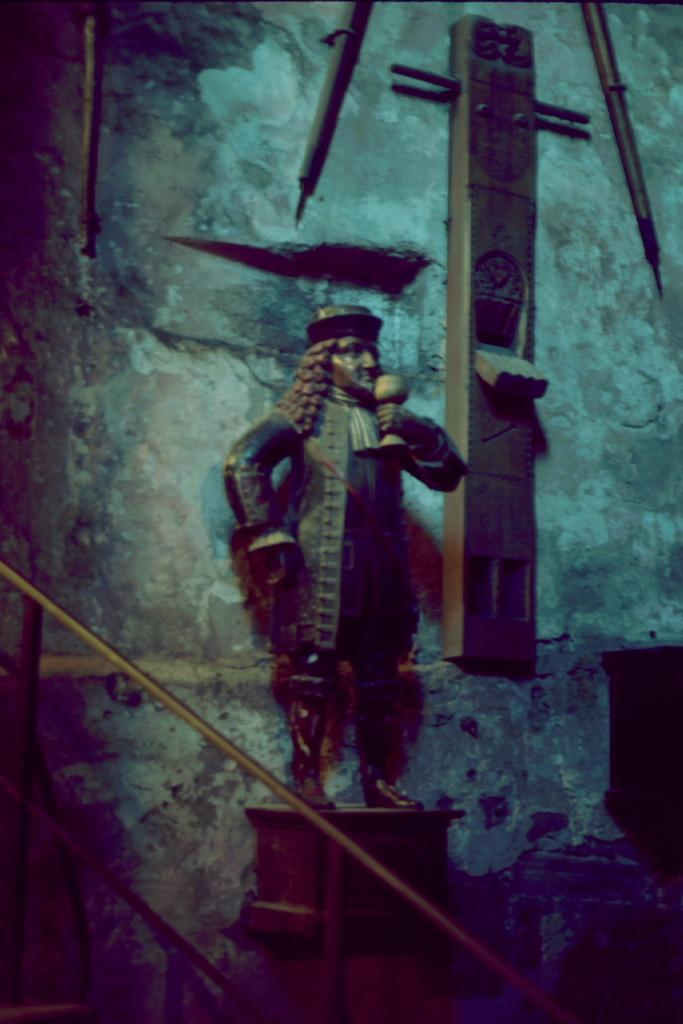What type of structure is present in the image? There are stairs in the image. What is the fence made of, and what does it surround? The fence is made of a metal rod, and it surrounds the stairs. What can be seen behind the fence? There is a statue and other artifacts on the wall behind the fence. Can you see the queen walking along the coast in the image? There is no queen or coast present in the image. 